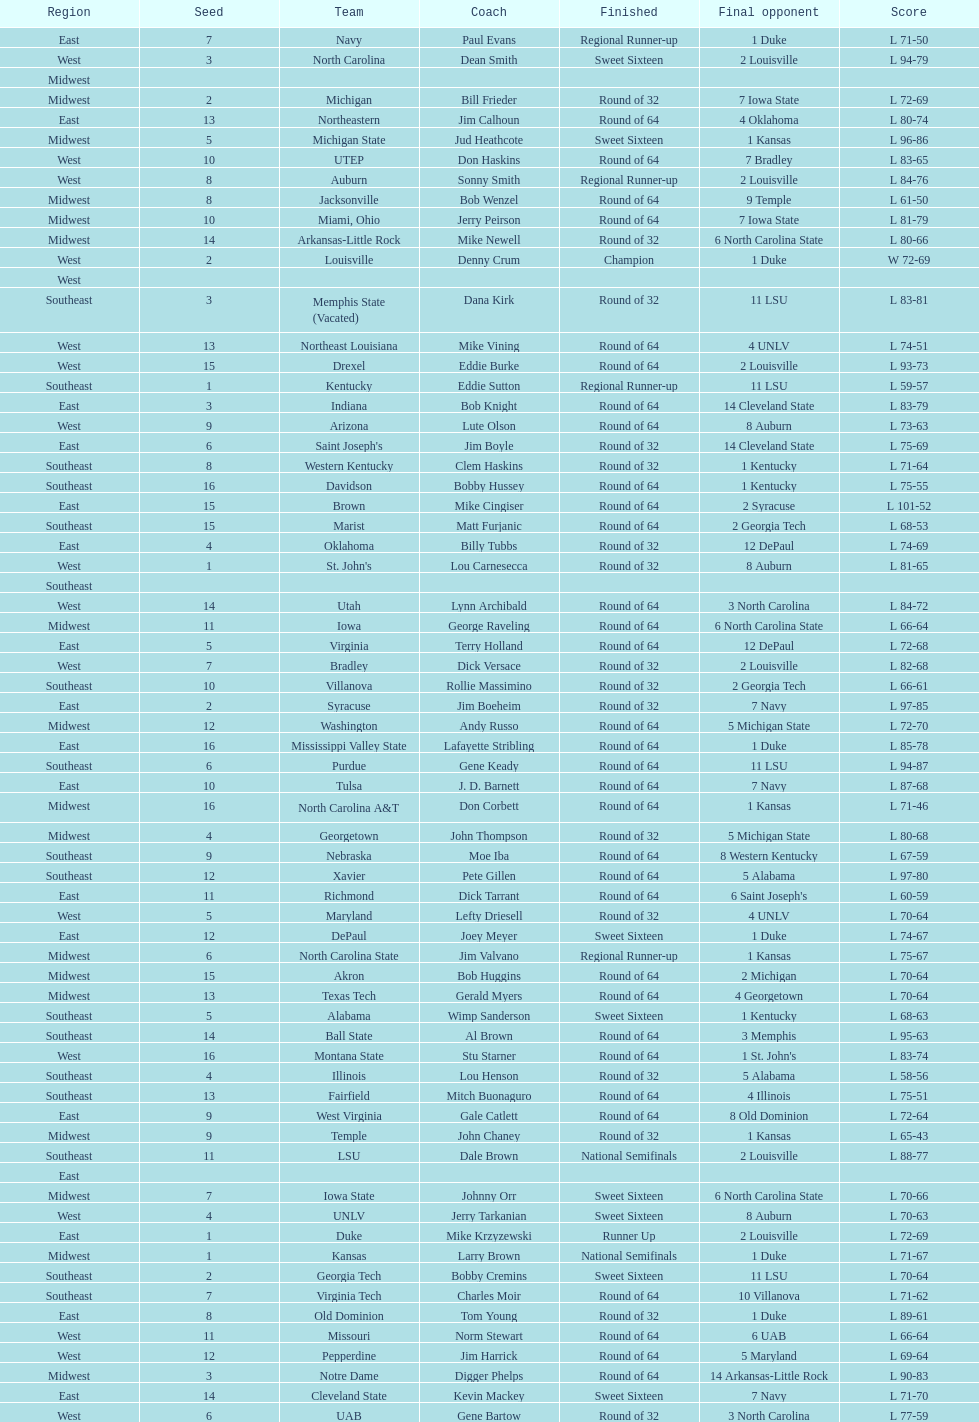How many teams are in the east region. 16. 